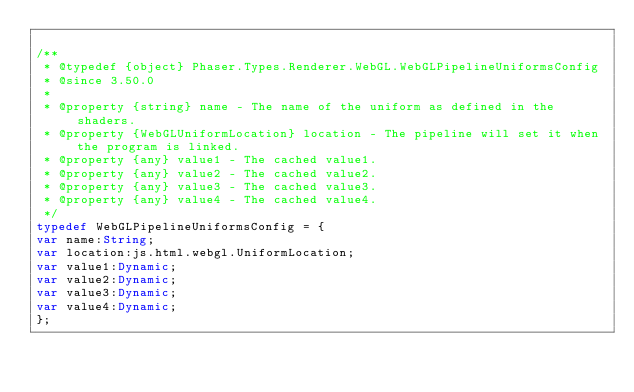Convert code to text. <code><loc_0><loc_0><loc_500><loc_500><_Haxe_>
/**
 * @typedef {object} Phaser.Types.Renderer.WebGL.WebGLPipelineUniformsConfig
 * @since 3.50.0
 *
 * @property {string} name - The name of the uniform as defined in the shaders.
 * @property {WebGLUniformLocation} location - The pipeline will set it when the program is linked.
 * @property {any} value1 - The cached value1.
 * @property {any} value2 - The cached value2.
 * @property {any} value3 - The cached value3.
 * @property {any} value4 - The cached value4.
 */
typedef WebGLPipelineUniformsConfig = {
var name:String;
var location:js.html.webgl.UniformLocation;
var value1:Dynamic;
var value2:Dynamic;
var value3:Dynamic;
var value4:Dynamic;
};
</code> 